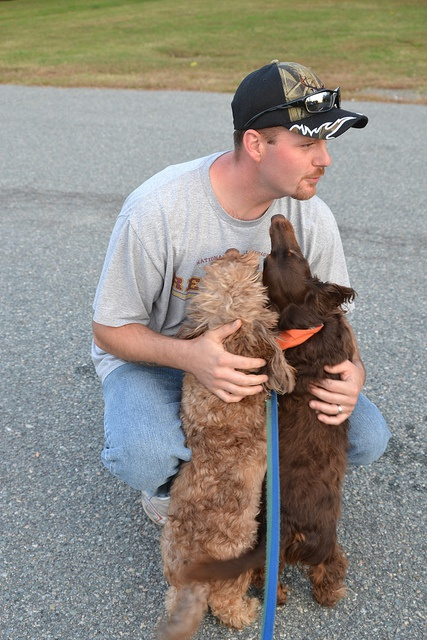Describe the objects in this image and their specific colors. I can see people in black, lightgray, darkgray, and salmon tones, dog in black, gray, tan, and brown tones, and dog in black, maroon, and gray tones in this image. 